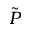<formula> <loc_0><loc_0><loc_500><loc_500>\tilde { P }</formula> 